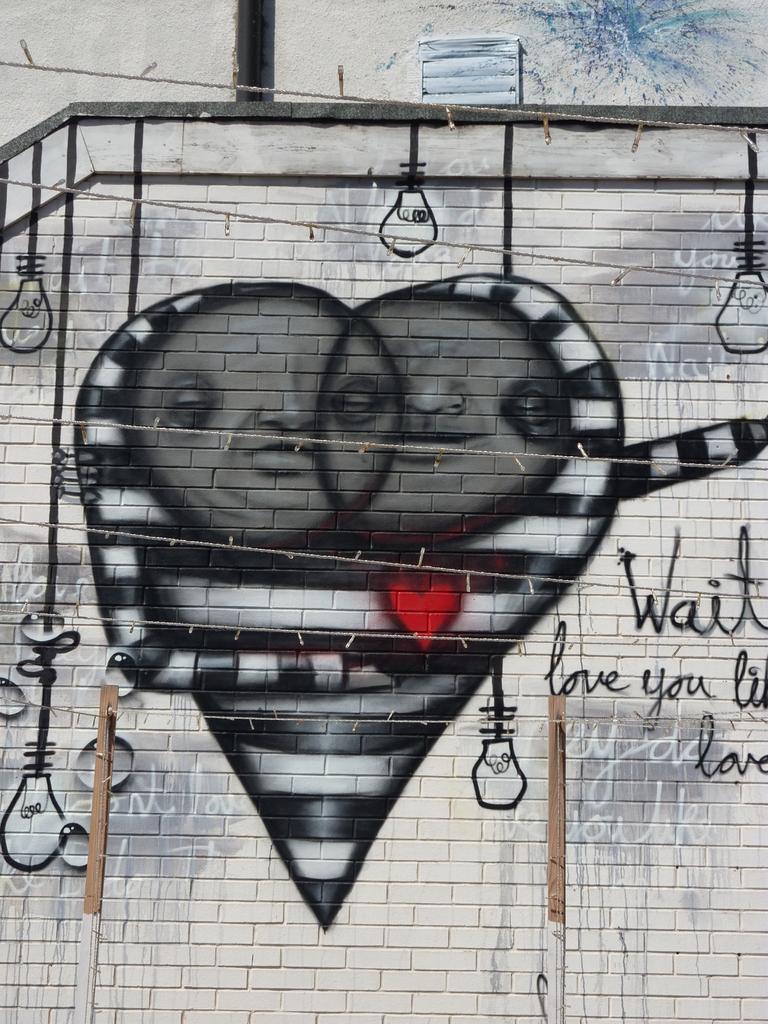How would you summarize this image in a sentence or two? In this image I see the wall on which there is an art and I see few words written and I see the sketch of light bulbs and I see the wires over here and I see red color heart over here. 